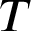Convert formula to latex. <formula><loc_0><loc_0><loc_500><loc_500>T</formula> 